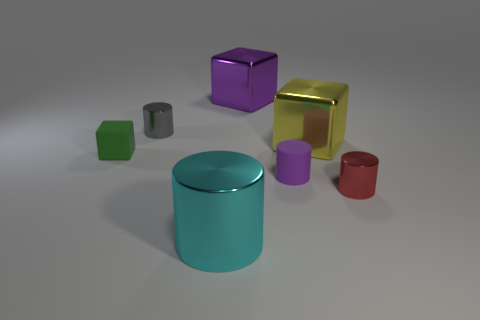There is a block that is on the right side of the large metal thing that is behind the gray cylinder; what is its size?
Offer a very short reply. Large. There is a large metallic thing that is the same color as the small matte cylinder; what shape is it?
Provide a succinct answer. Cube. How many blocks are either small red objects or large cyan shiny things?
Give a very brief answer. 0. There is a yellow cube; is its size the same as the gray object that is behind the cyan object?
Your response must be concise. No. Are there more red metal objects to the left of the purple metallic block than cylinders?
Offer a very short reply. No. There is a red cylinder that is made of the same material as the large purple cube; what is its size?
Offer a very short reply. Small. Is there a cylinder of the same color as the tiny cube?
Make the answer very short. No. What number of things are small purple cylinders or metallic cylinders right of the small gray metallic cylinder?
Offer a terse response. 3. Are there more big purple blocks than metal cylinders?
Give a very brief answer. No. What is the size of the cube that is the same color as the matte cylinder?
Provide a short and direct response. Large. 